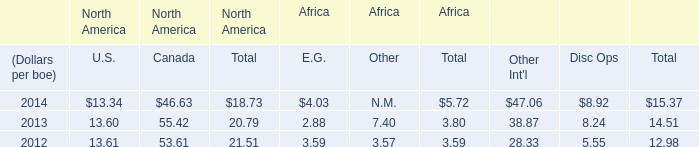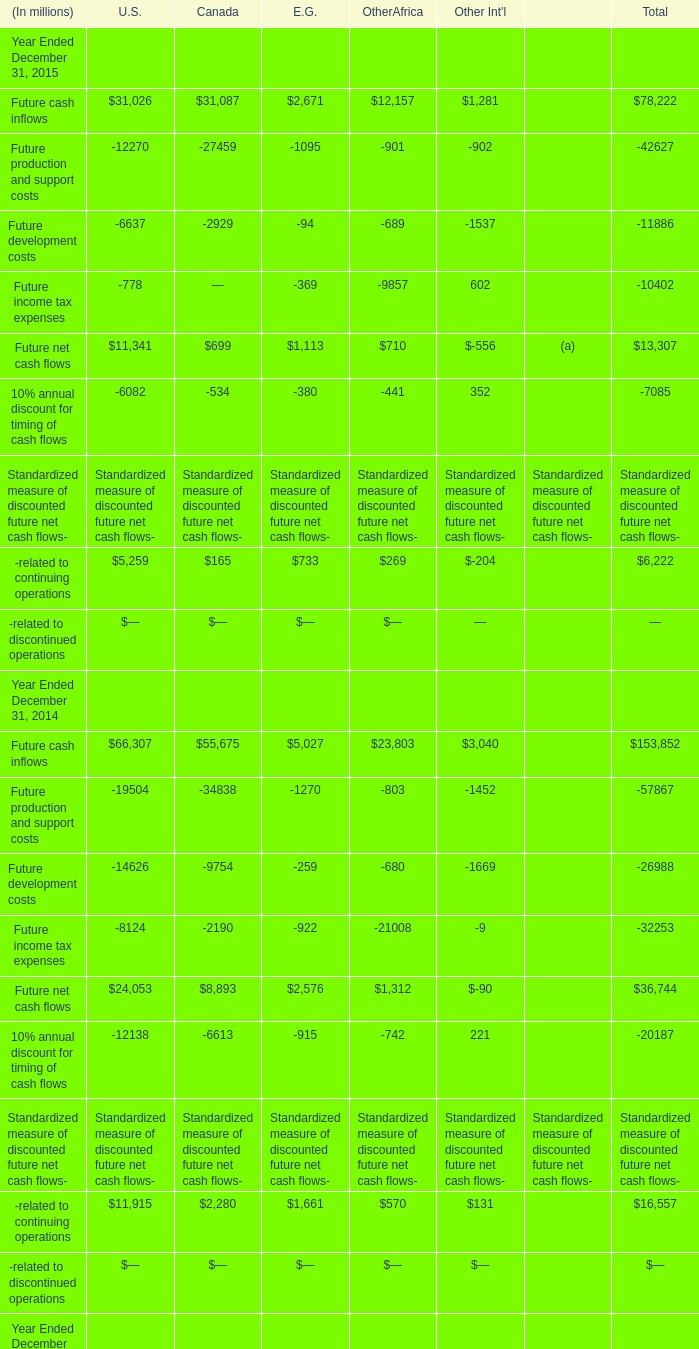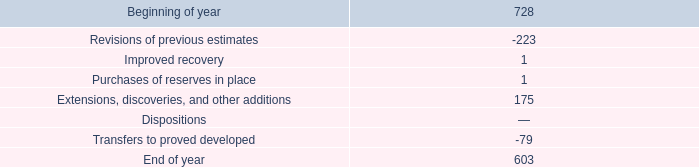what were total transfers from proved undeveloped to proved developed reserves in mmboe in the eagle ford and in the bakken ? 
Computations: (47 + 14)
Answer: 61.0. 